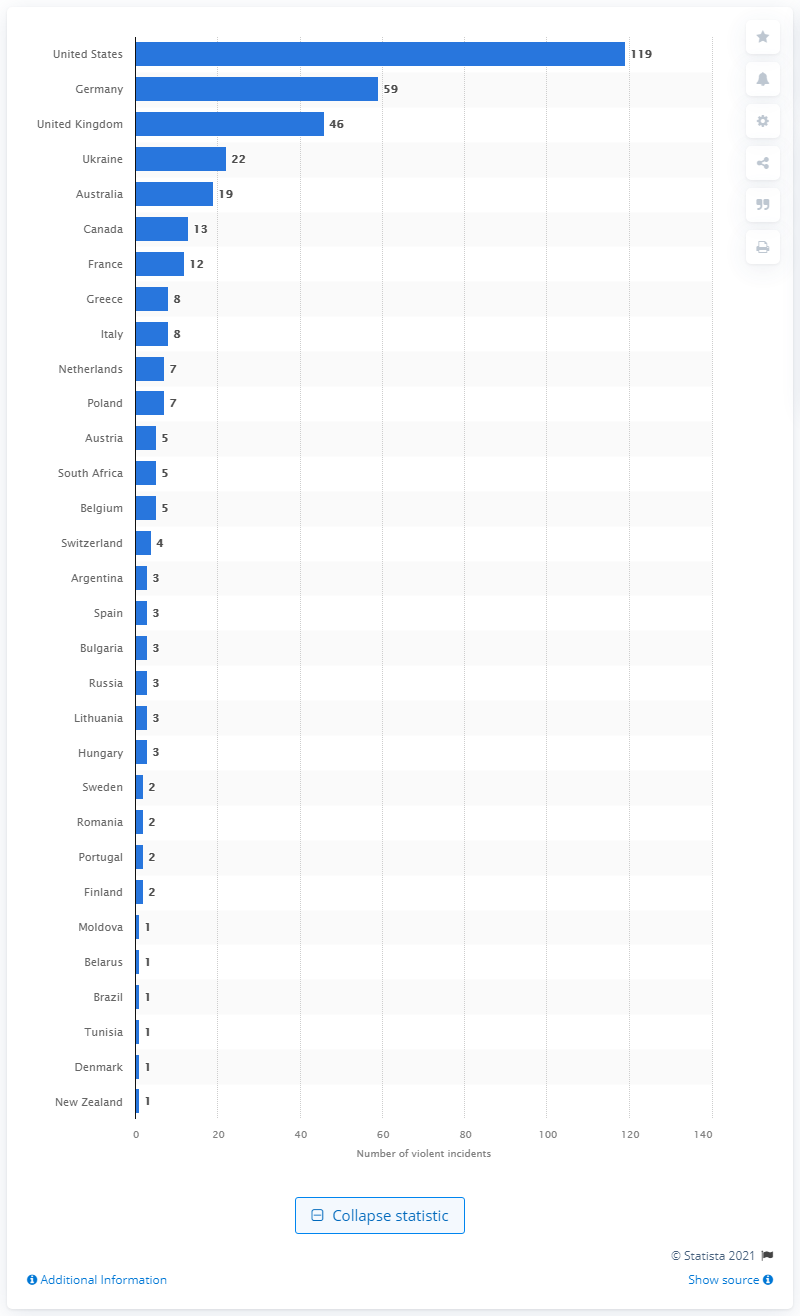Draw attention to some important aspects in this diagram. In 2020, there were 119 reported incidents of violent anti-Semitism in the United States. 